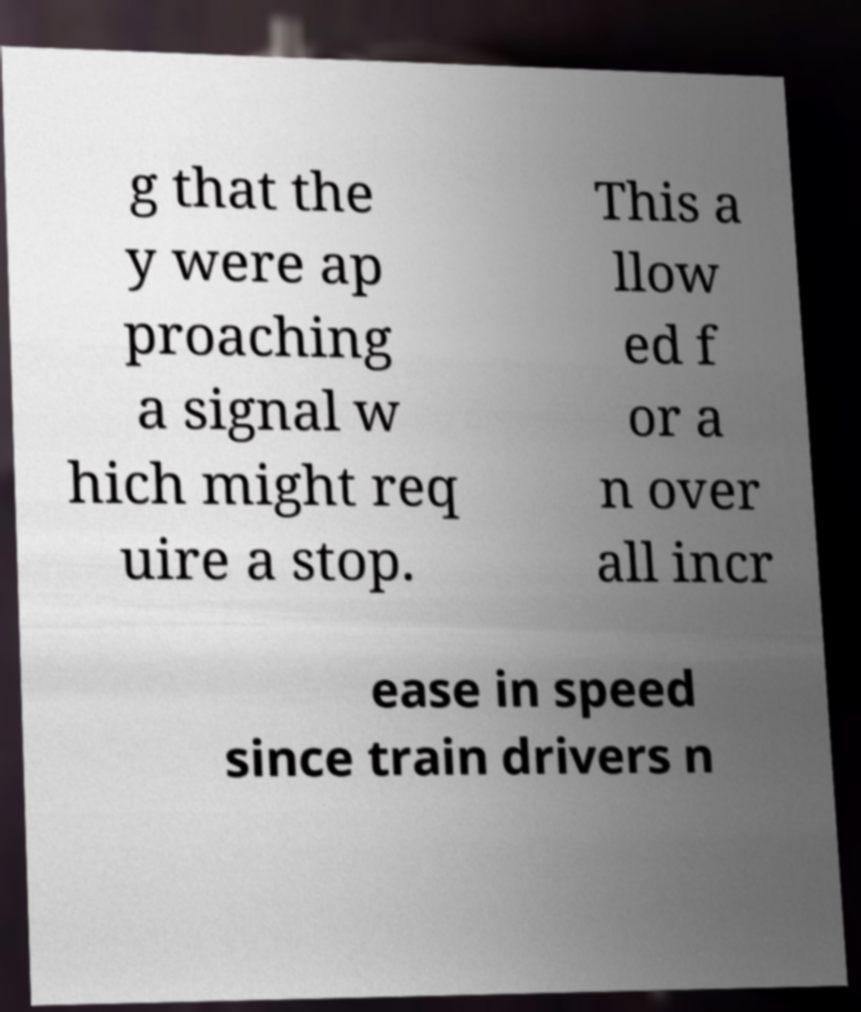Could you extract and type out the text from this image? g that the y were ap proaching a signal w hich might req uire a stop. This a llow ed f or a n over all incr ease in speed since train drivers n 